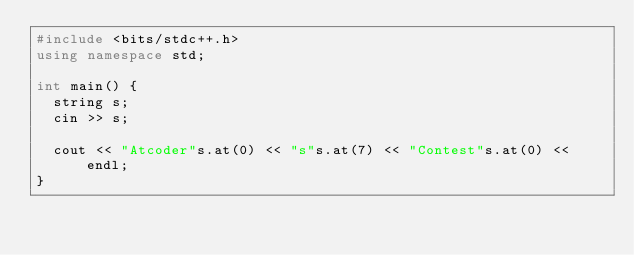Convert code to text. <code><loc_0><loc_0><loc_500><loc_500><_C++_>#include <bits/stdc++.h>
using namespace std;

int main() {
  string s;
  cin >> s;
  
  cout << "Atcoder"s.at(0) << "s"s.at(7) << "Contest"s.at(0) << endl;
}
</code> 